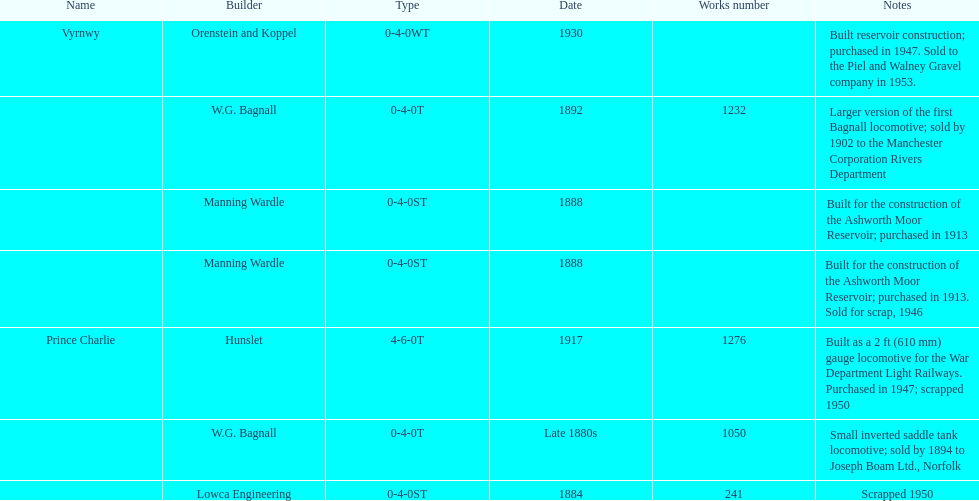What was the last locomotive? Vyrnwy. 